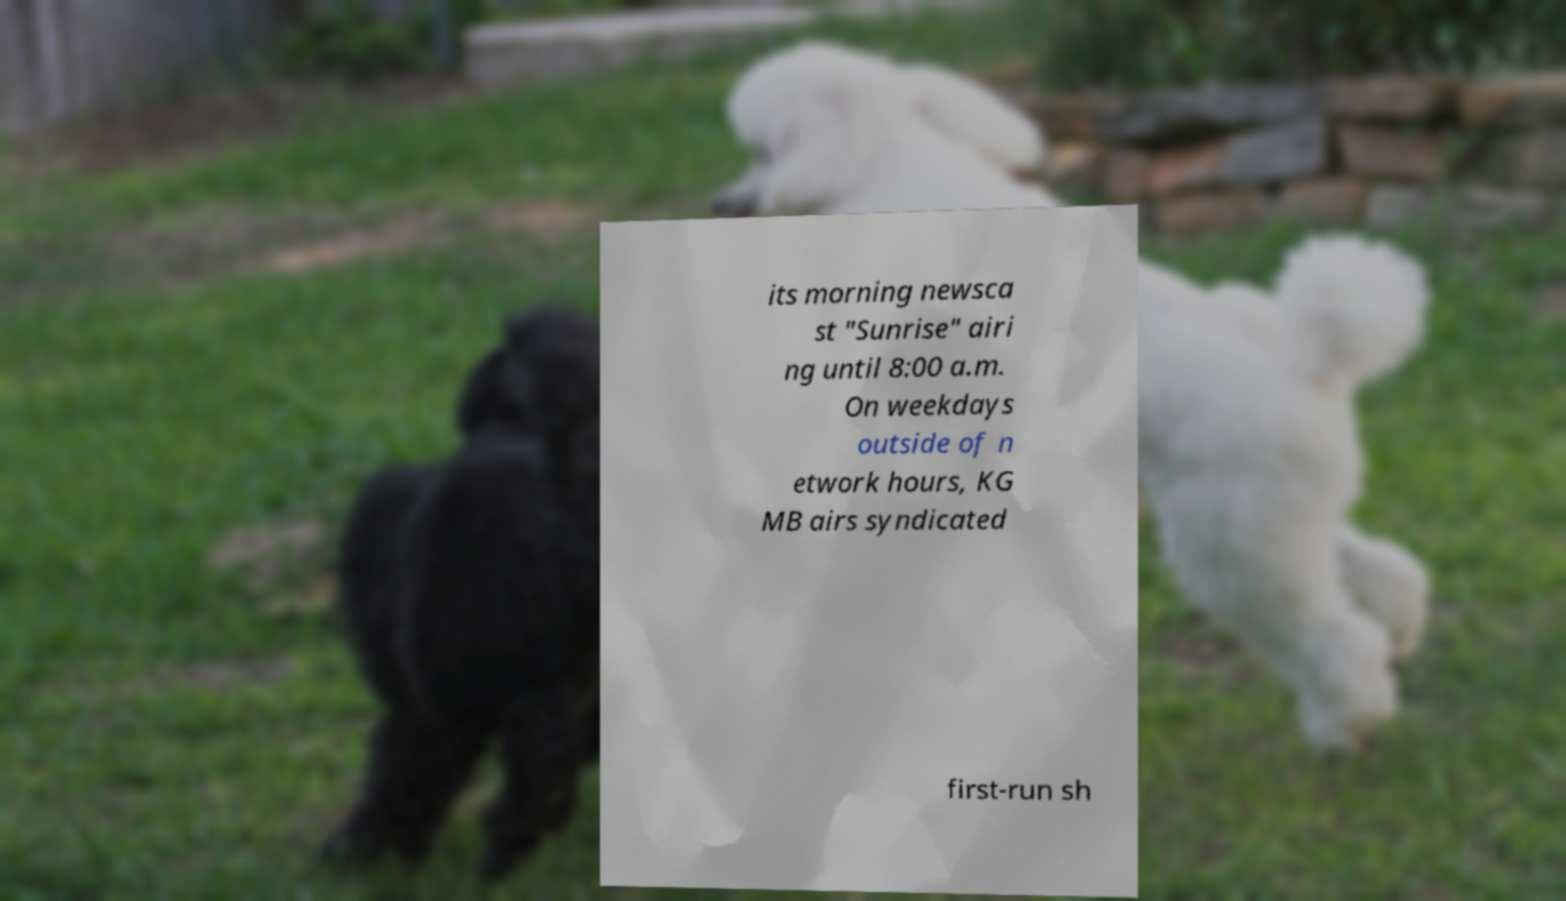What messages or text are displayed in this image? I need them in a readable, typed format. its morning newsca st "Sunrise" airi ng until 8:00 a.m. On weekdays outside of n etwork hours, KG MB airs syndicated first-run sh 